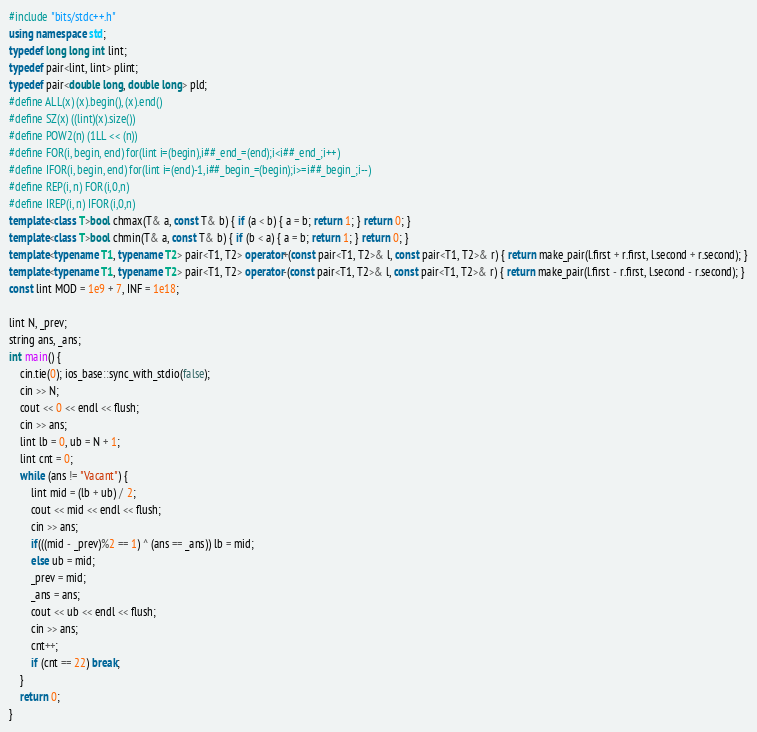<code> <loc_0><loc_0><loc_500><loc_500><_C++_>#include "bits/stdc++.h"
using namespace std;
typedef long long int lint;
typedef pair<lint, lint> plint;
typedef pair<double long, double long> pld;
#define ALL(x) (x).begin(), (x).end()
#define SZ(x) ((lint)(x).size())
#define POW2(n) (1LL << (n))
#define FOR(i, begin, end) for(lint i=(begin),i##_end_=(end);i<i##_end_;i++)
#define IFOR(i, begin, end) for(lint i=(end)-1,i##_begin_=(begin);i>=i##_begin_;i--)
#define REP(i, n) FOR(i,0,n)
#define IREP(i, n) IFOR(i,0,n)
template<class T>bool chmax(T& a, const T& b) { if (a < b) { a = b; return 1; } return 0; }
template<class T>bool chmin(T& a, const T& b) { if (b < a) { a = b; return 1; } return 0; }
template<typename T1, typename T2> pair<T1, T2> operator+(const pair<T1, T2>& l, const pair<T1, T2>& r) { return make_pair(l.first + r.first, l.second + r.second); }
template<typename T1, typename T2> pair<T1, T2> operator-(const pair<T1, T2>& l, const pair<T1, T2>& r) { return make_pair(l.first - r.first, l.second - r.second); }
const lint MOD = 1e9 + 7, INF = 1e18;

lint N, _prev;
string ans, _ans;
int main() {
	cin.tie(0); ios_base::sync_with_stdio(false);
	cin >> N;
	cout << 0 << endl << flush;
	cin >> ans;
	lint lb = 0, ub = N + 1;
	lint cnt = 0;
	while (ans != "Vacant") {
		lint mid = (lb + ub) / 2;
		cout << mid << endl << flush;
		cin >> ans;
		if(((mid - _prev)%2 == 1) ^ (ans == _ans)) lb = mid;
		else ub = mid;
		_prev = mid;
		_ans = ans;
		cout << ub << endl << flush;
		cin >> ans;
		cnt++;
		if (cnt == 22) break;
	}
	return 0;
}
</code> 